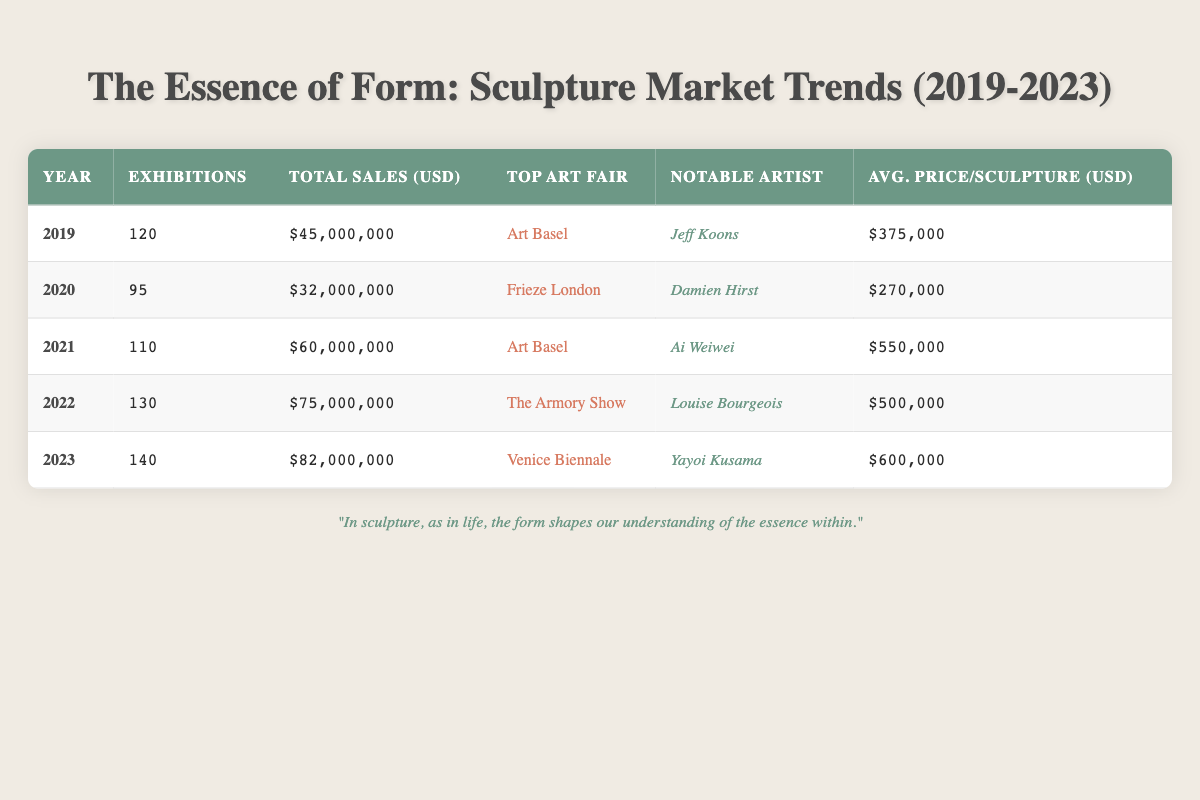What was the total sales value in 2022? The total sales value for the year 2022 is listed directly in the table as $75,000,000.
Answer: $75,000,000 Which artist had the highest average price per sculpture in 2021? The average price per sculpture for 2021 is provided in the table as $550,000, which belongs to the artist Ai Weiwei.
Answer: Ai Weiwei How many exhibitions were held in 2023 compared to 2019? In 2019, there were 120 exhibitions, and in 2023, there were 140 exhibitions. The difference is 140 - 120 = 20 exhibitions, indicating an increase from 2019 to 2023.
Answer: 20 Is it true that the total sales value decreased from 2019 to 2020? In 2019, the total sales value was $45,000,000, while in 2020, it was $32,000,000. Since $32,000,000 is less than $45,000,000, it is true that the total sales value decreased from 2019 to 2020.
Answer: Yes What is the average number of exhibitions from 2019 to 2023? The total number of exhibitions over the years is 120 + 95 + 110 + 130 + 140 = 595. There are 5 years, so the average is 595 / 5 = 119.
Answer: 119 In which year was the average price per sculpture highest and what was that price? The table shows that the highest average price per sculpture was in 2023 at $600,000. This can be inferred by comparing the average prices listed for each year.
Answer: 2023, $600,000 How much did the total sales value increase from 2021 to 2022? The total sales value for 2021 was $60,000,000, and for 2022 it was $75,000,000. The increase is calculated as $75,000,000 - $60,000,000 = $15,000,000.
Answer: $15,000,000 Was the top art fair in 2022 The Armory Show? According to the table, the top art fair in 2022 is noted as The Armory Show, confirming that the statement is true.
Answer: Yes If we consider the average prices per sculpture from 2019 to 2023, which year had the lowest average price? The average prices are $375,000 in 2019, $270,000 in 2020, $550,000 in 2021, $500,000 in 2022, and $600,000 in 2023. The lowest average price is thus $270,000 in 2020.
Answer: 2020, $270,000 